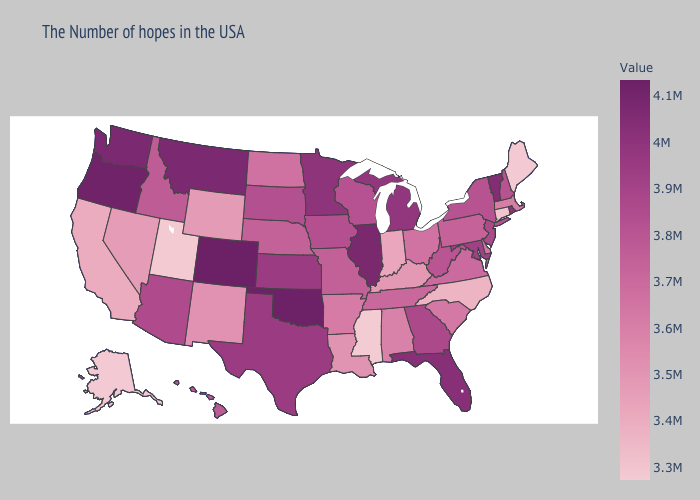Does Texas have the lowest value in the USA?
Keep it brief. No. Does Massachusetts have the lowest value in the USA?
Concise answer only. No. Which states have the lowest value in the South?
Give a very brief answer. Mississippi. Does Maine have the lowest value in the Northeast?
Keep it brief. Yes. Among the states that border Massachusetts , which have the highest value?
Be succinct. Vermont. 